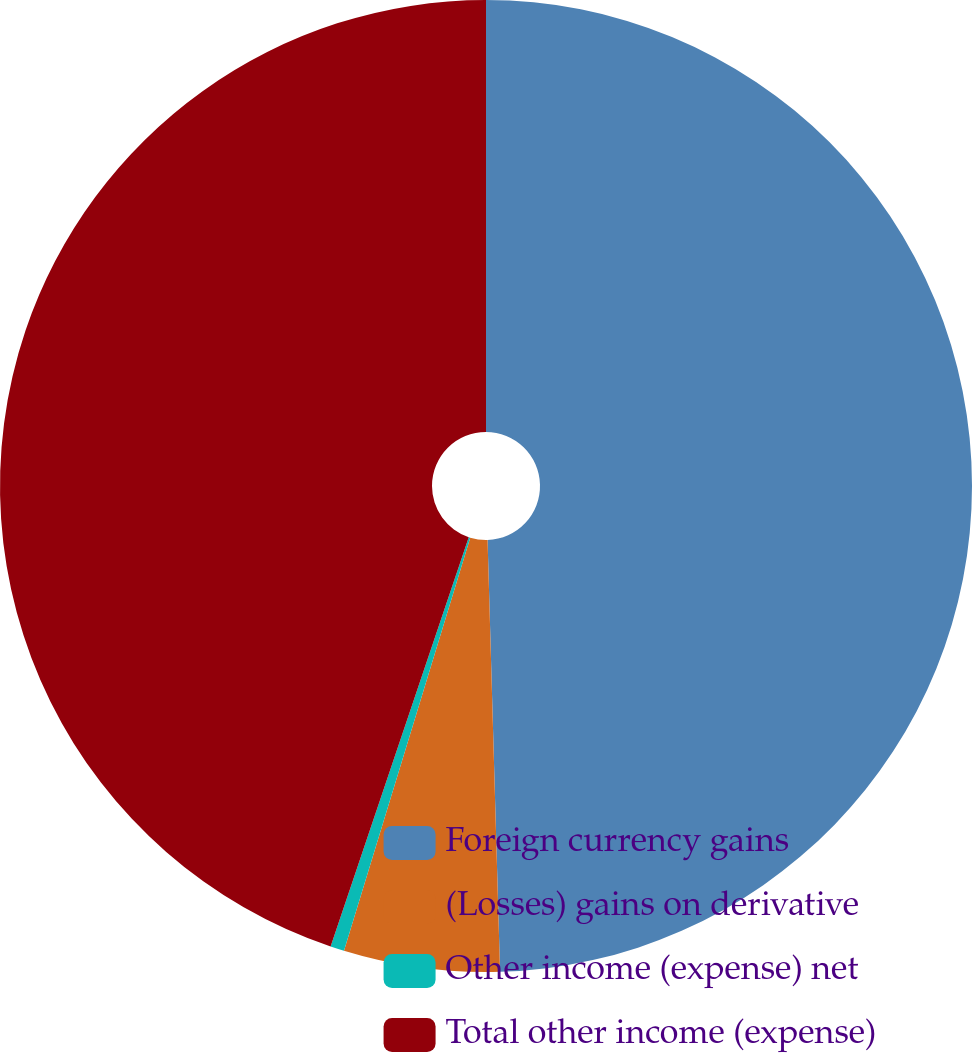Convert chart. <chart><loc_0><loc_0><loc_500><loc_500><pie_chart><fcel>Foreign currency gains<fcel>(Losses) gains on derivative<fcel>Other income (expense) net<fcel>Total other income (expense)<nl><fcel>49.54%<fcel>5.18%<fcel>0.46%<fcel>44.82%<nl></chart> 